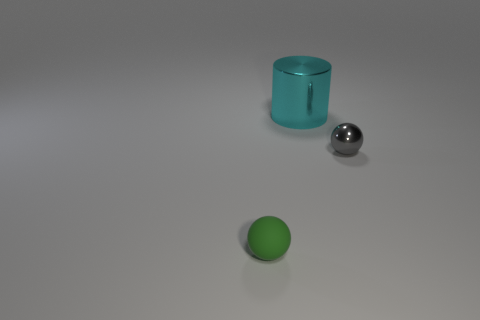Does the metallic object that is behind the gray ball have the same size as the small gray sphere?
Make the answer very short. No. How many things are tiny spheres that are to the left of the small gray metal sphere or objects that are to the left of the cyan metallic cylinder?
Provide a short and direct response. 1. Does the small ball that is behind the tiny green object have the same color as the large cylinder?
Make the answer very short. No. How many rubber things are large balls or cyan things?
Provide a short and direct response. 0. There is a matte thing; what shape is it?
Your answer should be very brief. Sphere. Are there any other things that are the same material as the gray object?
Your response must be concise. Yes. Does the large cyan cylinder have the same material as the small gray object?
Make the answer very short. Yes. Is there a tiny gray object that is on the right side of the large cyan shiny object on the left side of the small object that is to the right of the tiny green rubber sphere?
Provide a succinct answer. Yes. What number of other objects are there of the same shape as the gray thing?
Provide a succinct answer. 1. There is a thing that is both in front of the large cylinder and to the left of the gray metal object; what is its shape?
Offer a very short reply. Sphere. 